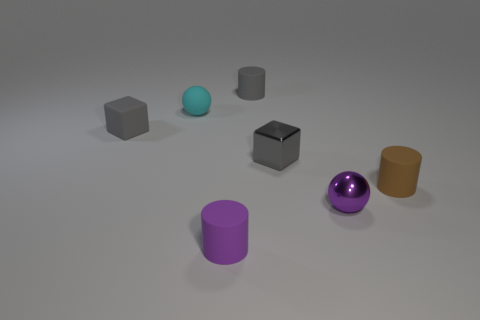Does the gray metallic block have the same size as the cyan rubber sphere?
Provide a short and direct response. Yes. Is the number of small cyan objects behind the rubber ball less than the number of rubber objects that are behind the purple matte thing?
Keep it short and to the point. Yes. There is a gray object that is in front of the cyan matte sphere and to the right of the cyan rubber ball; what size is it?
Offer a terse response. Small. There is a cylinder that is behind the rubber cylinder that is to the right of the metallic sphere; are there any gray objects that are to the right of it?
Provide a short and direct response. Yes. Are any large yellow metallic cylinders visible?
Provide a succinct answer. No. Are there more tiny brown matte cylinders to the left of the rubber ball than tiny gray metallic cubes in front of the small purple cylinder?
Your response must be concise. No. There is a purple cylinder that is made of the same material as the brown object; what size is it?
Your answer should be very brief. Small. There is a shiny ball that is to the right of the matte cylinder behind the brown cylinder that is to the right of the gray shiny block; what size is it?
Your answer should be compact. Small. There is a sphere to the right of the tiny gray shiny thing; what color is it?
Make the answer very short. Purple. Are there more tiny gray things on the right side of the cyan sphere than purple metal objects?
Ensure brevity in your answer.  Yes. 